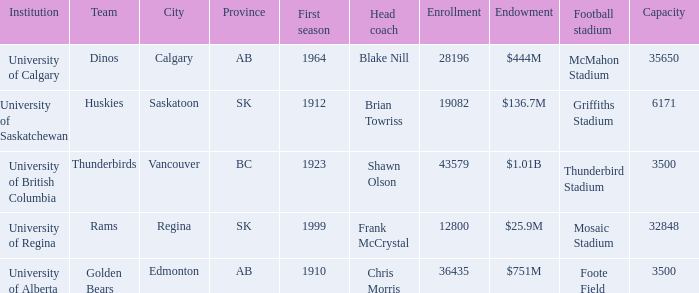What football stadium has a school enrollment of 43579? Thunderbird Stadium. 